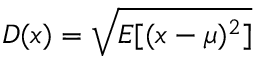Convert formula to latex. <formula><loc_0><loc_0><loc_500><loc_500>D ( x ) = { \sqrt { E [ ( x - \mu ) ^ { 2 } ] } }</formula> 